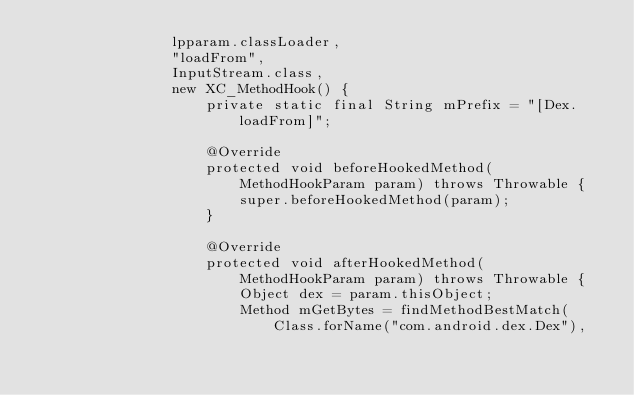<code> <loc_0><loc_0><loc_500><loc_500><_Java_>                lpparam.classLoader,
                "loadFrom",
                InputStream.class,
                new XC_MethodHook() {
                    private static final String mPrefix = "[Dex.loadFrom]";

                    @Override
                    protected void beforeHookedMethod(MethodHookParam param) throws Throwable {
                        super.beforeHookedMethod(param);
                    }

                    @Override
                    protected void afterHookedMethod(MethodHookParam param) throws Throwable {
                        Object dex = param.thisObject;
                        Method mGetBytes = findMethodBestMatch(Class.forName("com.android.dex.Dex"),</code> 